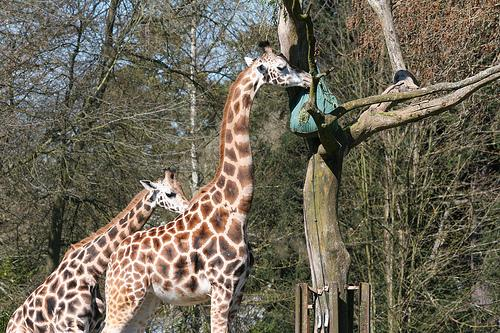Identify the main objects and their colors in the image. Tall giraffe, smaller giraffe, blue bag, bare tree branches, blue sky, wooden makeshift fence, green moss, dark brown spot, white spot, dark blue spot. What surrounds the tree at the bottom and what wood-related feature can be seen on it? A wooden makeshift fence surrounds the tree, and the bark of the tree is visible. How many giraffe ears can be seen and what color are they? There are two visible giraffe ears - one white and one tan ear. What is the state of the trees and the sky in the image? There are lots of bare tall trees, leafless trees behind the giraffes, and the sky is blue and cloudless. What are the two main animals in the image and what is their relative size? There are two giraffes - an adult giraffe and a baby giraffe, with the adult being larger than the baby. Describe the appearance of the large giraffe. The large giraffe has brown and black spots, a slanted eye, wide hind leg, and brown and white spots. Describe the overall setting of the image and the time it was taken. The setting includes giraffes, trees, and a makeshift fence in a natural environment during the daytime with a cloudless sky. Explain what the two giraffes are doing in the image. The tall giraffe is looking at the tree, and the smaller giraffe is standing behind it. Choose two actions performed by the giraffes and describe them. A giraffe is eating and standing next to another giraffe. What is hanging on the tree and what color is it? A blue bag is hanging on the tree. 